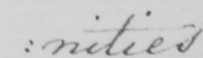What text is written in this handwritten line? : nities 